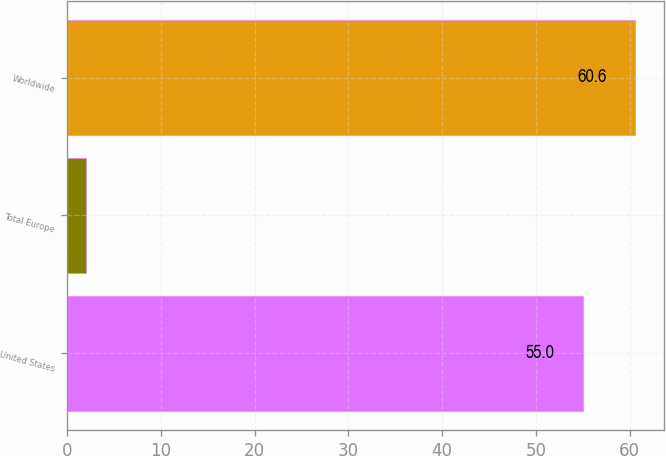Convert chart to OTSL. <chart><loc_0><loc_0><loc_500><loc_500><bar_chart><fcel>United States<fcel>Total Europe<fcel>Worldwide<nl><fcel>55<fcel>2<fcel>60.6<nl></chart> 